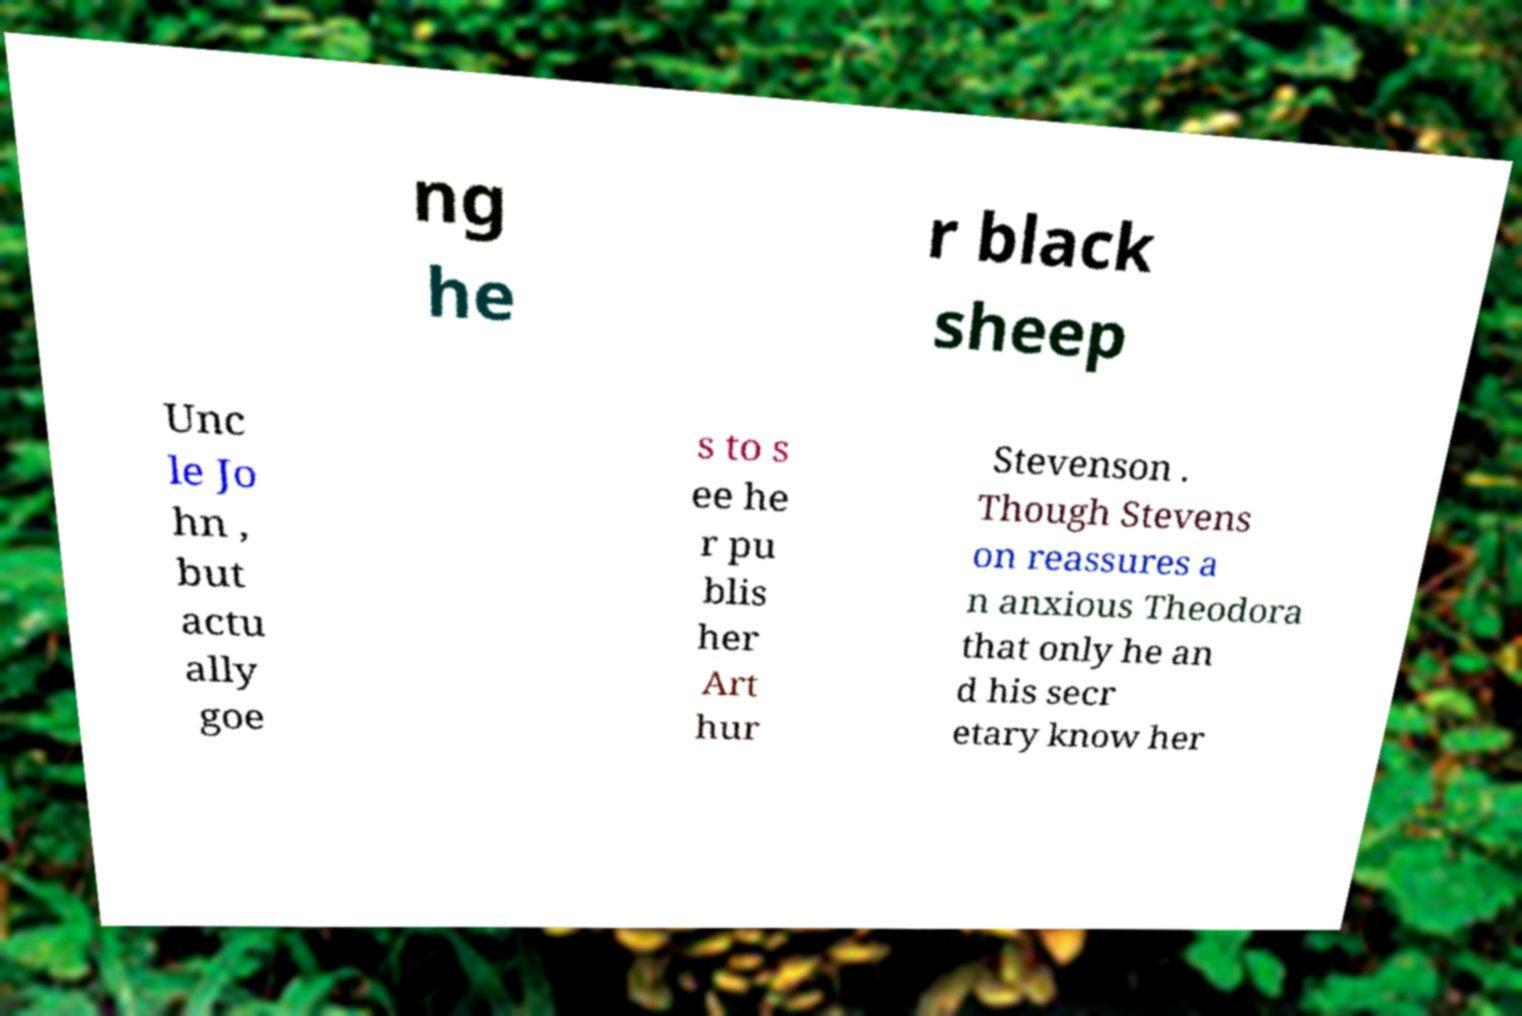Can you read and provide the text displayed in the image?This photo seems to have some interesting text. Can you extract and type it out for me? ng he r black sheep Unc le Jo hn , but actu ally goe s to s ee he r pu blis her Art hur Stevenson . Though Stevens on reassures a n anxious Theodora that only he an d his secr etary know her 